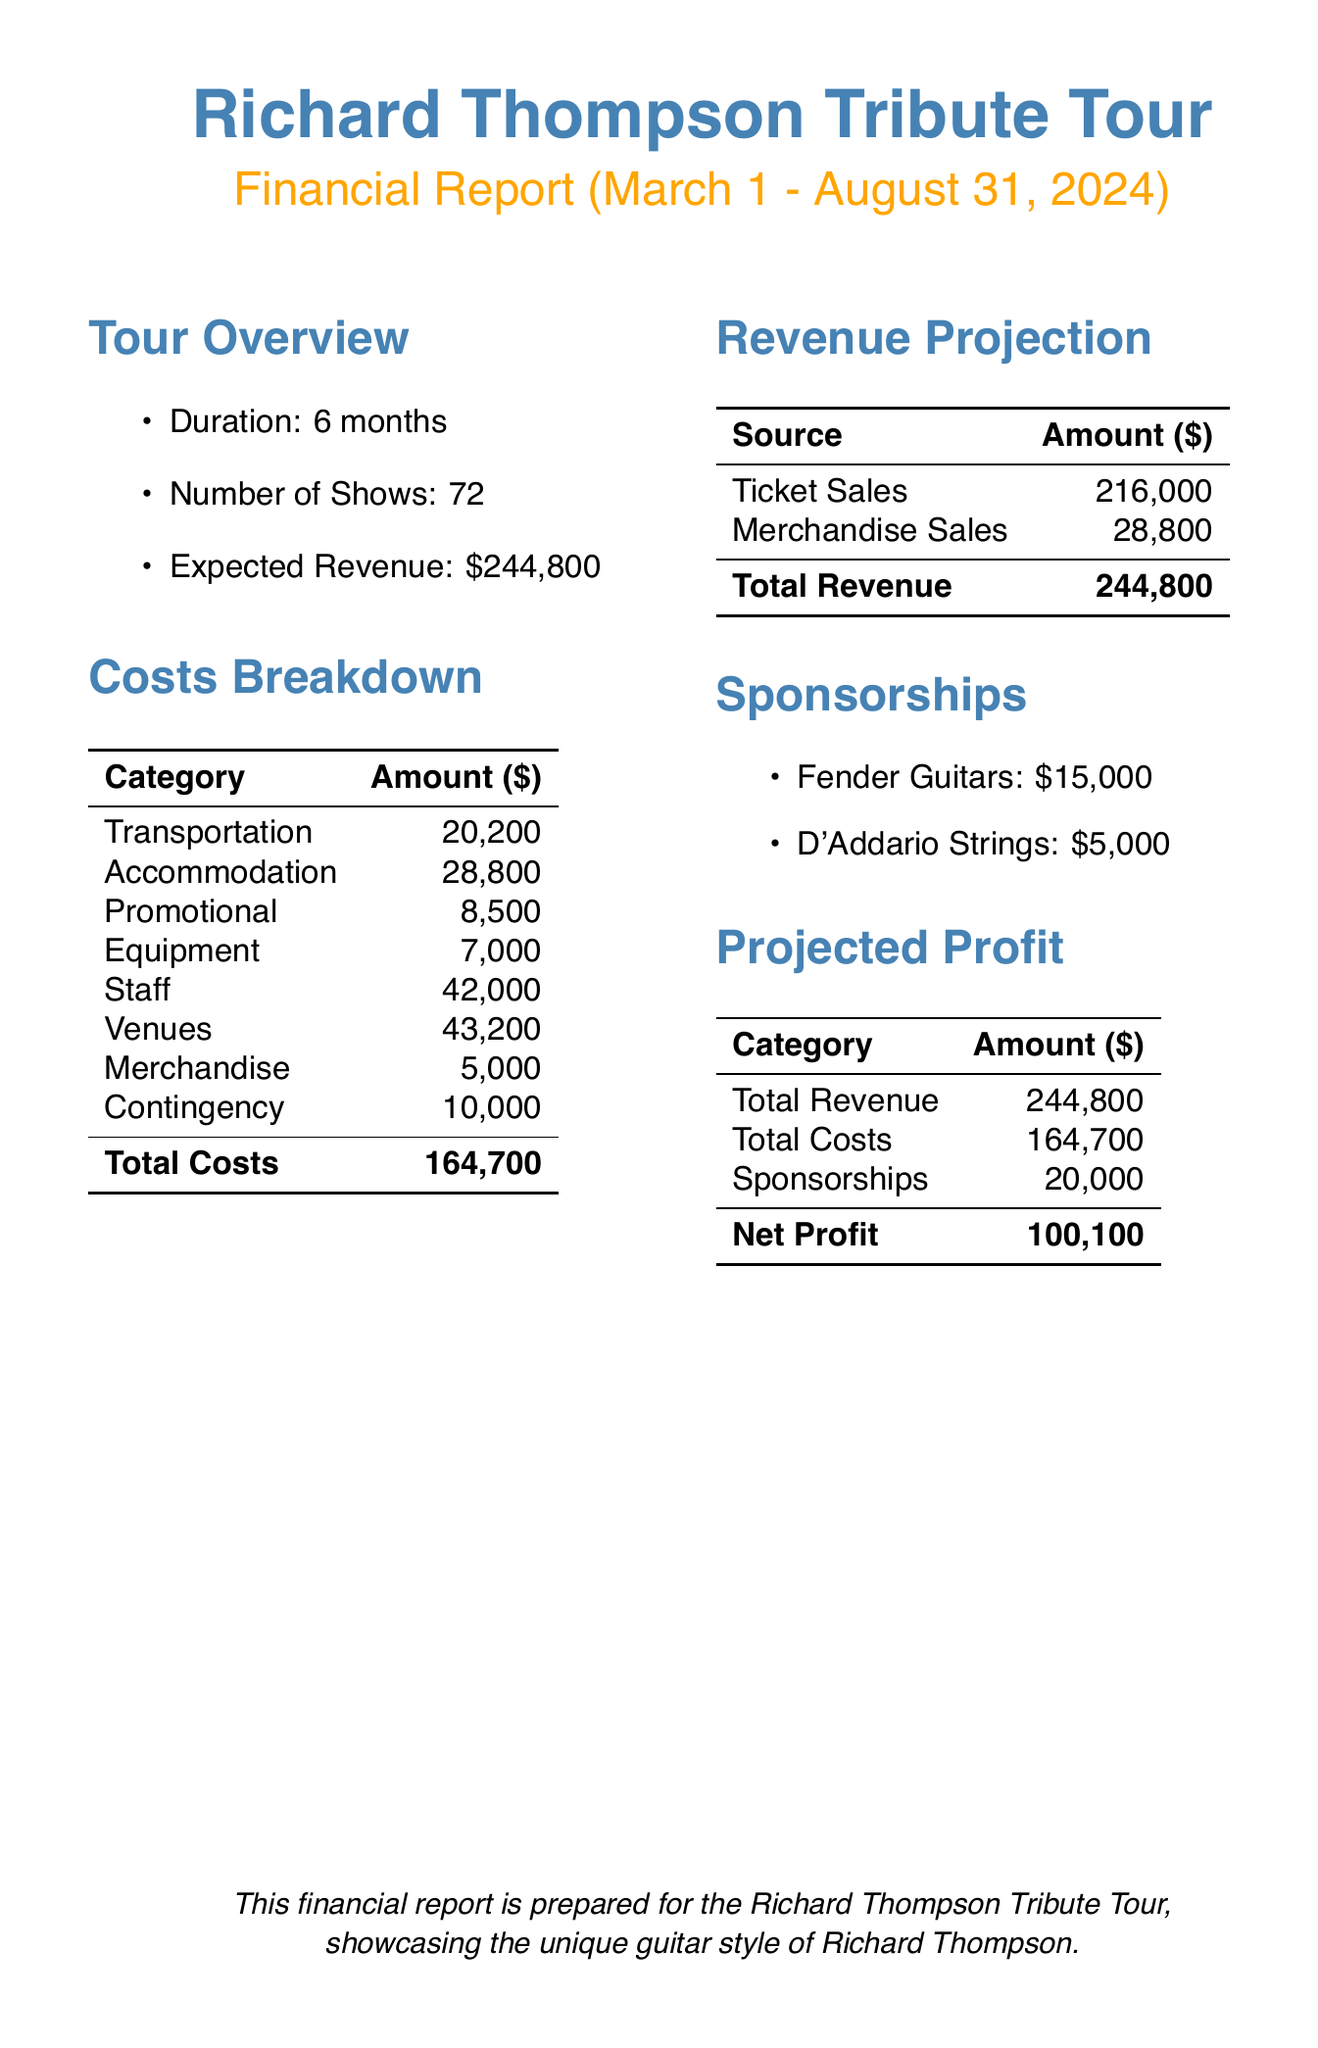What is the tour name? The tour name is specified at the beginning of the document, which is the Richard Thompson Tribute Tour.
Answer: Richard Thompson Tribute Tour What is the total number of shows? The total number of shows is clearly stated as 72 in the tour overview section.
Answer: 72 How much is allocated for transportation costs? Transportation costs are broken down in the costs breakdown table, totaling 20,200 dollars.
Answer: 20,200 What is the amount for promotional costs? Promotional costs are listed in the costs breakdown section, which sums up to 8,500 dollars.
Answer: 8,500 What is the expected revenue from ticket sales? The expected revenue from ticket sales is mentioned in the revenue projection section, listed as 216,000 dollars.
Answer: 216,000 What is the total revenue? Total revenue can be calculated from the revenue projection table, which shows the sum of ticket and merchandise sales, amounting to 244,800 dollars.
Answer: 244,800 What are the total sponsorship amounts? The sponsorship amounts from the two listed sponsors can be summed up to 20,000 dollars.
Answer: 20,000 What is the net profit projection? The net profit is calculated in the projected profit table and amounts to 100,100 dollars.
Answer: 100,100 What period does the financial report cover? The financial report specifies the time frame it covers, which is from March 1 to August 31, 2024.
Answer: March 1 - August 31, 2024 